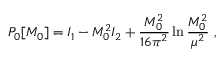Convert formula to latex. <formula><loc_0><loc_0><loc_500><loc_500>P _ { 0 } [ M _ { 0 } ] = I _ { 1 } - M _ { 0 } ^ { 2 } I _ { 2 } + { \frac { M _ { 0 } ^ { 2 } } { 1 6 \pi ^ { 2 } } } \ln { \frac { M _ { 0 } ^ { 2 } } { \mu ^ { 2 } } } ,</formula> 